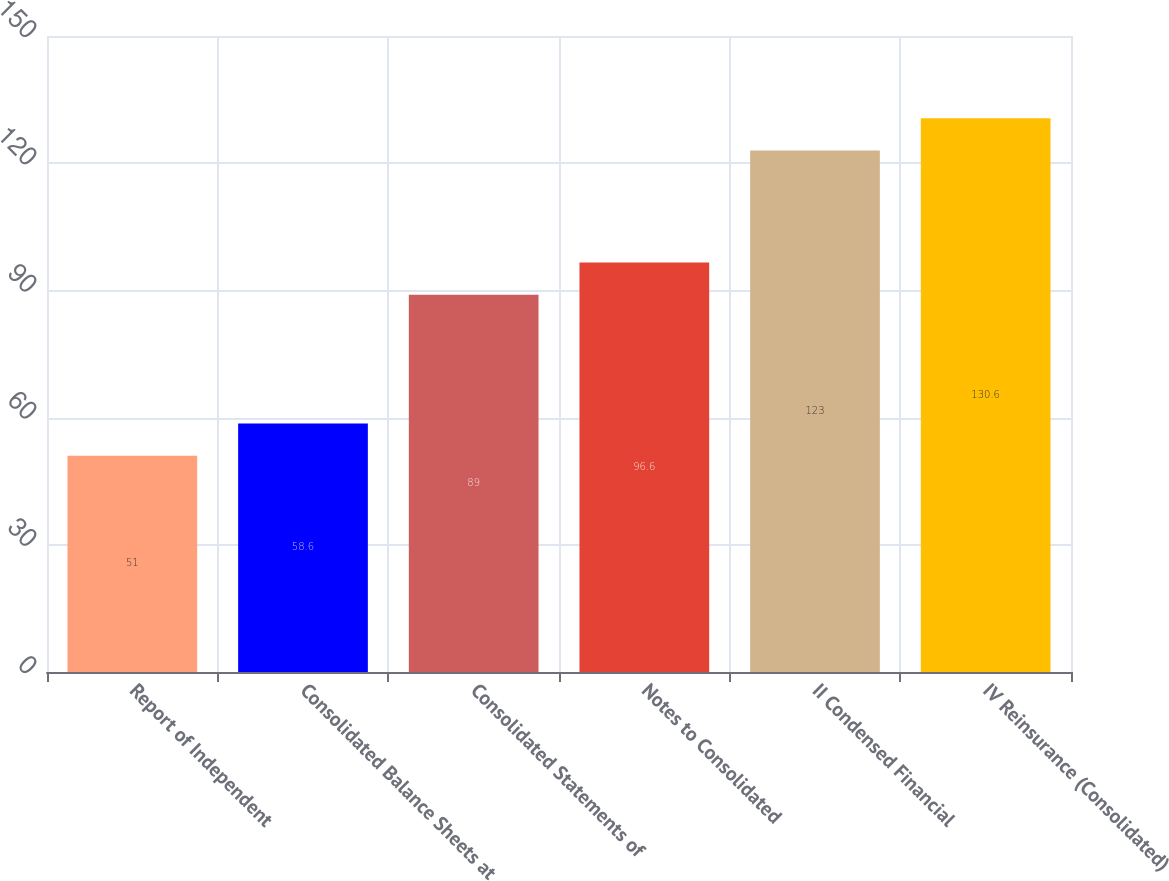<chart> <loc_0><loc_0><loc_500><loc_500><bar_chart><fcel>Report of Independent<fcel>Consolidated Balance Sheets at<fcel>Consolidated Statements of<fcel>Notes to Consolidated<fcel>II Condensed Financial<fcel>IV Reinsurance (Consolidated)<nl><fcel>51<fcel>58.6<fcel>89<fcel>96.6<fcel>123<fcel>130.6<nl></chart> 